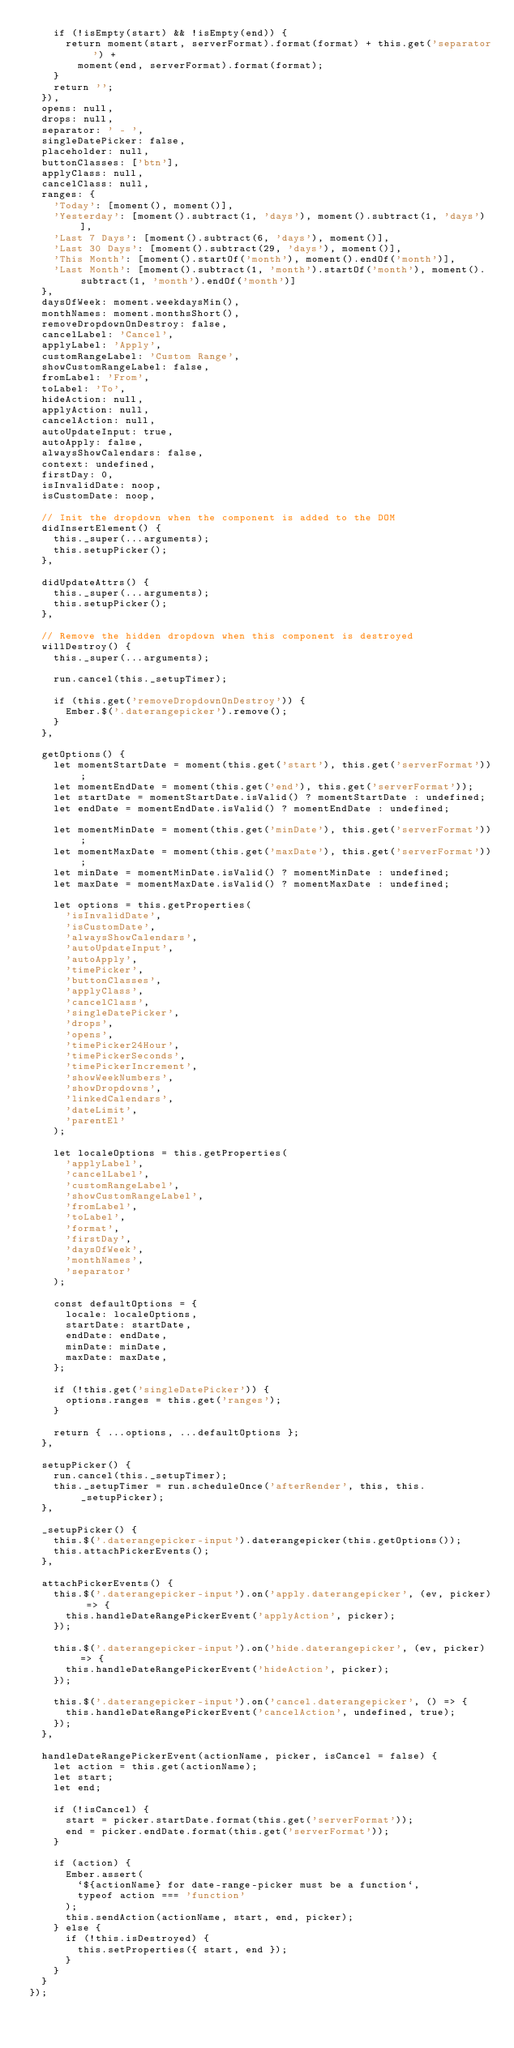<code> <loc_0><loc_0><loc_500><loc_500><_JavaScript_>    if (!isEmpty(start) && !isEmpty(end)) {
      return moment(start, serverFormat).format(format) + this.get('separator') +
        moment(end, serverFormat).format(format);
    }
    return '';
  }),
  opens: null,
  drops: null,
  separator: ' - ',
  singleDatePicker: false,
  placeholder: null,
  buttonClasses: ['btn'],
  applyClass: null,
  cancelClass: null,
  ranges: {
    'Today': [moment(), moment()],
    'Yesterday': [moment().subtract(1, 'days'), moment().subtract(1, 'days')],
    'Last 7 Days': [moment().subtract(6, 'days'), moment()],
    'Last 30 Days': [moment().subtract(29, 'days'), moment()],
    'This Month': [moment().startOf('month'), moment().endOf('month')],
    'Last Month': [moment().subtract(1, 'month').startOf('month'), moment().subtract(1, 'month').endOf('month')]
  },
  daysOfWeek: moment.weekdaysMin(),
  monthNames: moment.monthsShort(),
  removeDropdownOnDestroy: false,
  cancelLabel: 'Cancel',
  applyLabel: 'Apply',
  customRangeLabel: 'Custom Range',
  showCustomRangeLabel: false,
  fromLabel: 'From',
  toLabel: 'To',
  hideAction: null,
  applyAction: null,
  cancelAction: null,
  autoUpdateInput: true,
  autoApply: false,
  alwaysShowCalendars: false,
  context: undefined,
  firstDay: 0,
  isInvalidDate: noop,
  isCustomDate: noop,

  // Init the dropdown when the component is added to the DOM
  didInsertElement() {
    this._super(...arguments);
    this.setupPicker();
  },

  didUpdateAttrs() {
    this._super(...arguments);
    this.setupPicker();
  },

  // Remove the hidden dropdown when this component is destroyed
  willDestroy() {
    this._super(...arguments);

    run.cancel(this._setupTimer);

    if (this.get('removeDropdownOnDestroy')) {
      Ember.$('.daterangepicker').remove();
    }
  },

  getOptions() {
    let momentStartDate = moment(this.get('start'), this.get('serverFormat'));
    let momentEndDate = moment(this.get('end'), this.get('serverFormat'));
    let startDate = momentStartDate.isValid() ? momentStartDate : undefined;
    let endDate = momentEndDate.isValid() ? momentEndDate : undefined;

    let momentMinDate = moment(this.get('minDate'), this.get('serverFormat'));
    let momentMaxDate = moment(this.get('maxDate'), this.get('serverFormat'));
    let minDate = momentMinDate.isValid() ? momentMinDate : undefined;
    let maxDate = momentMaxDate.isValid() ? momentMaxDate : undefined;

    let options = this.getProperties(
      'isInvalidDate',
      'isCustomDate',
      'alwaysShowCalendars',
      'autoUpdateInput',
      'autoApply',
      'timePicker',
      'buttonClasses',
      'applyClass',
      'cancelClass',
      'singleDatePicker',
      'drops',
      'opens',
      'timePicker24Hour',
      'timePickerSeconds',
      'timePickerIncrement',
      'showWeekNumbers',
      'showDropdowns',
      'linkedCalendars',
      'dateLimit',
      'parentEl'
    );

    let localeOptions = this.getProperties(
      'applyLabel',
      'cancelLabel',
      'customRangeLabel',
      'showCustomRangeLabel',
      'fromLabel',
      'toLabel',
      'format',
      'firstDay',
      'daysOfWeek',
      'monthNames',
      'separator'
    );

    const defaultOptions = {
      locale: localeOptions,
      startDate: startDate,
      endDate: endDate,
      minDate: minDate,
      maxDate: maxDate,
    };

    if (!this.get('singleDatePicker')) {
      options.ranges = this.get('ranges');
    }

    return { ...options, ...defaultOptions };
  },

  setupPicker() {
    run.cancel(this._setupTimer);
    this._setupTimer = run.scheduleOnce('afterRender', this, this._setupPicker);
  },

  _setupPicker() {
    this.$('.daterangepicker-input').daterangepicker(this.getOptions());
    this.attachPickerEvents();
  },

  attachPickerEvents() {
    this.$('.daterangepicker-input').on('apply.daterangepicker', (ev, picker) => {
      this.handleDateRangePickerEvent('applyAction', picker);
    });

    this.$('.daterangepicker-input').on('hide.daterangepicker', (ev, picker) => {
      this.handleDateRangePickerEvent('hideAction', picker);
    });

    this.$('.daterangepicker-input').on('cancel.daterangepicker', () => {
      this.handleDateRangePickerEvent('cancelAction', undefined, true);
    });
  },

  handleDateRangePickerEvent(actionName, picker, isCancel = false) {
    let action = this.get(actionName);
    let start;
    let end;

    if (!isCancel) {
      start = picker.startDate.format(this.get('serverFormat'));
      end = picker.endDate.format(this.get('serverFormat'));
    }

    if (action) {
      Ember.assert(
        `${actionName} for date-range-picker must be a function`,
        typeof action === 'function'
      );
      this.sendAction(actionName, start, end, picker);
    } else {
      if (!this.isDestroyed) {
        this.setProperties({ start, end });
      }
    }
  }
});
</code> 